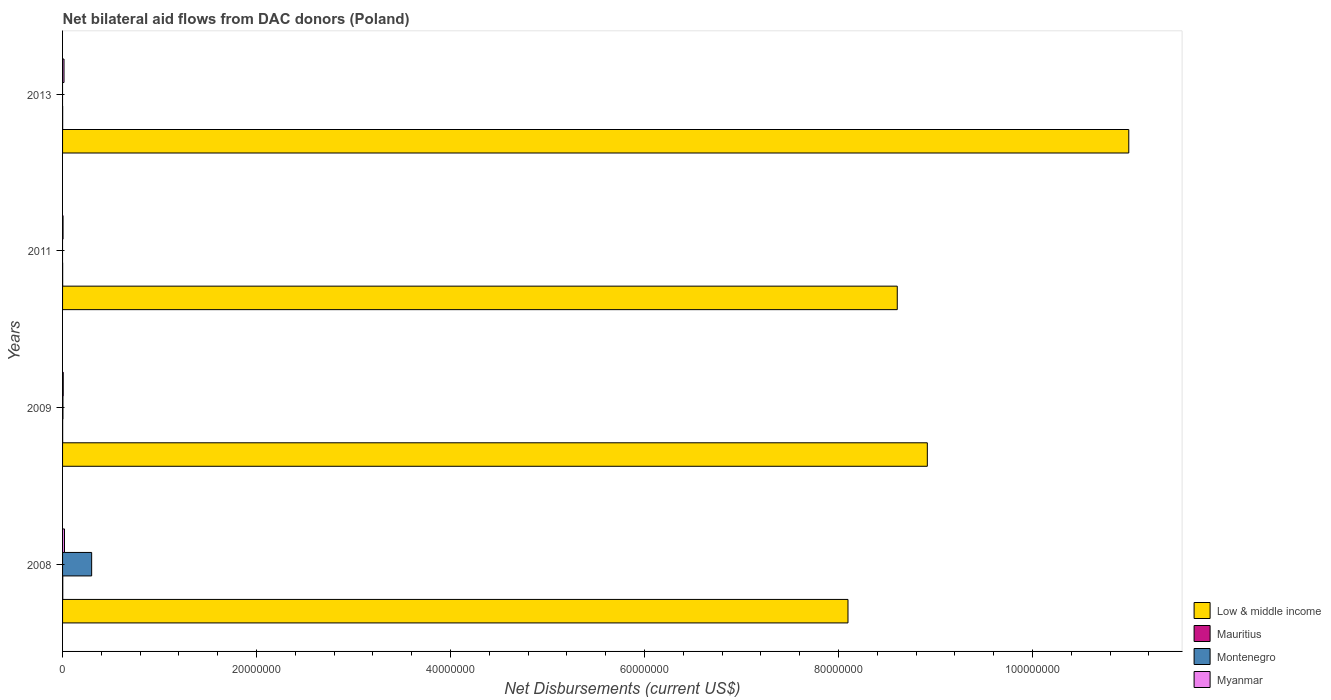Are the number of bars per tick equal to the number of legend labels?
Your answer should be very brief. No. Are the number of bars on each tick of the Y-axis equal?
Your answer should be compact. No. How many bars are there on the 1st tick from the top?
Offer a terse response. 3. How many bars are there on the 1st tick from the bottom?
Your answer should be compact. 4. In how many cases, is the number of bars for a given year not equal to the number of legend labels?
Provide a short and direct response. 2. Across all years, what is the minimum net bilateral aid flows in Montenegro?
Your response must be concise. 0. In which year was the net bilateral aid flows in Mauritius maximum?
Give a very brief answer. 2008. What is the difference between the net bilateral aid flows in Low & middle income in 2009 and the net bilateral aid flows in Montenegro in 2008?
Offer a terse response. 8.62e+07. What is the average net bilateral aid flows in Low & middle income per year?
Give a very brief answer. 9.15e+07. In the year 2008, what is the difference between the net bilateral aid flows in Montenegro and net bilateral aid flows in Mauritius?
Offer a very short reply. 2.98e+06. What is the ratio of the net bilateral aid flows in Low & middle income in 2008 to that in 2011?
Give a very brief answer. 0.94. Is the net bilateral aid flows in Mauritius in 2008 less than that in 2013?
Make the answer very short. No. What is the difference between the highest and the second highest net bilateral aid flows in Low & middle income?
Provide a succinct answer. 2.08e+07. In how many years, is the net bilateral aid flows in Low & middle income greater than the average net bilateral aid flows in Low & middle income taken over all years?
Give a very brief answer. 1. Is the sum of the net bilateral aid flows in Low & middle income in 2009 and 2013 greater than the maximum net bilateral aid flows in Mauritius across all years?
Provide a succinct answer. Yes. Is it the case that in every year, the sum of the net bilateral aid flows in Low & middle income and net bilateral aid flows in Myanmar is greater than the sum of net bilateral aid flows in Montenegro and net bilateral aid flows in Mauritius?
Make the answer very short. Yes. Is it the case that in every year, the sum of the net bilateral aid flows in Low & middle income and net bilateral aid flows in Myanmar is greater than the net bilateral aid flows in Montenegro?
Keep it short and to the point. Yes. Are all the bars in the graph horizontal?
Give a very brief answer. Yes. How many years are there in the graph?
Your answer should be compact. 4. Does the graph contain any zero values?
Ensure brevity in your answer.  Yes. Where does the legend appear in the graph?
Offer a terse response. Bottom right. How are the legend labels stacked?
Your answer should be very brief. Vertical. What is the title of the graph?
Your answer should be compact. Net bilateral aid flows from DAC donors (Poland). What is the label or title of the X-axis?
Give a very brief answer. Net Disbursements (current US$). What is the label or title of the Y-axis?
Offer a very short reply. Years. What is the Net Disbursements (current US$) in Low & middle income in 2008?
Make the answer very short. 8.10e+07. What is the Net Disbursements (current US$) in Montenegro in 2008?
Make the answer very short. 3.00e+06. What is the Net Disbursements (current US$) of Low & middle income in 2009?
Your response must be concise. 8.92e+07. What is the Net Disbursements (current US$) in Mauritius in 2009?
Your answer should be compact. 10000. What is the Net Disbursements (current US$) of Montenegro in 2009?
Give a very brief answer. 4.00e+04. What is the Net Disbursements (current US$) of Myanmar in 2009?
Your answer should be compact. 7.00e+04. What is the Net Disbursements (current US$) in Low & middle income in 2011?
Make the answer very short. 8.61e+07. What is the Net Disbursements (current US$) of Mauritius in 2011?
Your response must be concise. 10000. What is the Net Disbursements (current US$) of Montenegro in 2011?
Your response must be concise. 0. What is the Net Disbursements (current US$) of Myanmar in 2011?
Your response must be concise. 5.00e+04. What is the Net Disbursements (current US$) of Low & middle income in 2013?
Offer a terse response. 1.10e+08. What is the Net Disbursements (current US$) of Mauritius in 2013?
Give a very brief answer. 10000. Across all years, what is the maximum Net Disbursements (current US$) of Low & middle income?
Keep it short and to the point. 1.10e+08. Across all years, what is the maximum Net Disbursements (current US$) of Mauritius?
Give a very brief answer. 2.00e+04. Across all years, what is the minimum Net Disbursements (current US$) of Low & middle income?
Offer a very short reply. 8.10e+07. Across all years, what is the minimum Net Disbursements (current US$) in Mauritius?
Offer a terse response. 10000. Across all years, what is the minimum Net Disbursements (current US$) in Montenegro?
Provide a succinct answer. 0. What is the total Net Disbursements (current US$) of Low & middle income in the graph?
Give a very brief answer. 3.66e+08. What is the total Net Disbursements (current US$) of Mauritius in the graph?
Make the answer very short. 5.00e+04. What is the total Net Disbursements (current US$) in Montenegro in the graph?
Ensure brevity in your answer.  3.04e+06. What is the difference between the Net Disbursements (current US$) in Low & middle income in 2008 and that in 2009?
Ensure brevity in your answer.  -8.18e+06. What is the difference between the Net Disbursements (current US$) of Montenegro in 2008 and that in 2009?
Provide a short and direct response. 2.96e+06. What is the difference between the Net Disbursements (current US$) of Low & middle income in 2008 and that in 2011?
Offer a very short reply. -5.08e+06. What is the difference between the Net Disbursements (current US$) in Myanmar in 2008 and that in 2011?
Your answer should be very brief. 1.50e+05. What is the difference between the Net Disbursements (current US$) of Low & middle income in 2008 and that in 2013?
Your answer should be very brief. -2.90e+07. What is the difference between the Net Disbursements (current US$) in Low & middle income in 2009 and that in 2011?
Make the answer very short. 3.10e+06. What is the difference between the Net Disbursements (current US$) in Low & middle income in 2009 and that in 2013?
Ensure brevity in your answer.  -2.08e+07. What is the difference between the Net Disbursements (current US$) of Myanmar in 2009 and that in 2013?
Provide a succinct answer. -8.00e+04. What is the difference between the Net Disbursements (current US$) in Low & middle income in 2011 and that in 2013?
Provide a short and direct response. -2.39e+07. What is the difference between the Net Disbursements (current US$) of Myanmar in 2011 and that in 2013?
Offer a very short reply. -1.00e+05. What is the difference between the Net Disbursements (current US$) of Low & middle income in 2008 and the Net Disbursements (current US$) of Mauritius in 2009?
Your answer should be compact. 8.10e+07. What is the difference between the Net Disbursements (current US$) of Low & middle income in 2008 and the Net Disbursements (current US$) of Montenegro in 2009?
Keep it short and to the point. 8.09e+07. What is the difference between the Net Disbursements (current US$) of Low & middle income in 2008 and the Net Disbursements (current US$) of Myanmar in 2009?
Ensure brevity in your answer.  8.09e+07. What is the difference between the Net Disbursements (current US$) in Montenegro in 2008 and the Net Disbursements (current US$) in Myanmar in 2009?
Give a very brief answer. 2.93e+06. What is the difference between the Net Disbursements (current US$) in Low & middle income in 2008 and the Net Disbursements (current US$) in Mauritius in 2011?
Make the answer very short. 8.10e+07. What is the difference between the Net Disbursements (current US$) in Low & middle income in 2008 and the Net Disbursements (current US$) in Myanmar in 2011?
Provide a succinct answer. 8.09e+07. What is the difference between the Net Disbursements (current US$) in Mauritius in 2008 and the Net Disbursements (current US$) in Myanmar in 2011?
Your answer should be compact. -3.00e+04. What is the difference between the Net Disbursements (current US$) of Montenegro in 2008 and the Net Disbursements (current US$) of Myanmar in 2011?
Keep it short and to the point. 2.95e+06. What is the difference between the Net Disbursements (current US$) of Low & middle income in 2008 and the Net Disbursements (current US$) of Mauritius in 2013?
Offer a terse response. 8.10e+07. What is the difference between the Net Disbursements (current US$) in Low & middle income in 2008 and the Net Disbursements (current US$) in Myanmar in 2013?
Your answer should be very brief. 8.08e+07. What is the difference between the Net Disbursements (current US$) in Mauritius in 2008 and the Net Disbursements (current US$) in Myanmar in 2013?
Provide a short and direct response. -1.30e+05. What is the difference between the Net Disbursements (current US$) in Montenegro in 2008 and the Net Disbursements (current US$) in Myanmar in 2013?
Provide a short and direct response. 2.85e+06. What is the difference between the Net Disbursements (current US$) of Low & middle income in 2009 and the Net Disbursements (current US$) of Mauritius in 2011?
Provide a succinct answer. 8.92e+07. What is the difference between the Net Disbursements (current US$) of Low & middle income in 2009 and the Net Disbursements (current US$) of Myanmar in 2011?
Your response must be concise. 8.91e+07. What is the difference between the Net Disbursements (current US$) of Low & middle income in 2009 and the Net Disbursements (current US$) of Mauritius in 2013?
Provide a succinct answer. 8.92e+07. What is the difference between the Net Disbursements (current US$) of Low & middle income in 2009 and the Net Disbursements (current US$) of Myanmar in 2013?
Provide a short and direct response. 8.90e+07. What is the difference between the Net Disbursements (current US$) in Mauritius in 2009 and the Net Disbursements (current US$) in Myanmar in 2013?
Give a very brief answer. -1.40e+05. What is the difference between the Net Disbursements (current US$) of Montenegro in 2009 and the Net Disbursements (current US$) of Myanmar in 2013?
Keep it short and to the point. -1.10e+05. What is the difference between the Net Disbursements (current US$) in Low & middle income in 2011 and the Net Disbursements (current US$) in Mauritius in 2013?
Make the answer very short. 8.60e+07. What is the difference between the Net Disbursements (current US$) in Low & middle income in 2011 and the Net Disbursements (current US$) in Myanmar in 2013?
Provide a succinct answer. 8.59e+07. What is the difference between the Net Disbursements (current US$) of Mauritius in 2011 and the Net Disbursements (current US$) of Myanmar in 2013?
Your answer should be compact. -1.40e+05. What is the average Net Disbursements (current US$) of Low & middle income per year?
Your response must be concise. 9.15e+07. What is the average Net Disbursements (current US$) in Mauritius per year?
Your answer should be very brief. 1.25e+04. What is the average Net Disbursements (current US$) of Montenegro per year?
Make the answer very short. 7.60e+05. What is the average Net Disbursements (current US$) of Myanmar per year?
Provide a succinct answer. 1.18e+05. In the year 2008, what is the difference between the Net Disbursements (current US$) in Low & middle income and Net Disbursements (current US$) in Mauritius?
Your response must be concise. 8.10e+07. In the year 2008, what is the difference between the Net Disbursements (current US$) in Low & middle income and Net Disbursements (current US$) in Montenegro?
Your response must be concise. 7.80e+07. In the year 2008, what is the difference between the Net Disbursements (current US$) of Low & middle income and Net Disbursements (current US$) of Myanmar?
Give a very brief answer. 8.08e+07. In the year 2008, what is the difference between the Net Disbursements (current US$) of Mauritius and Net Disbursements (current US$) of Montenegro?
Offer a terse response. -2.98e+06. In the year 2008, what is the difference between the Net Disbursements (current US$) of Mauritius and Net Disbursements (current US$) of Myanmar?
Ensure brevity in your answer.  -1.80e+05. In the year 2008, what is the difference between the Net Disbursements (current US$) in Montenegro and Net Disbursements (current US$) in Myanmar?
Keep it short and to the point. 2.80e+06. In the year 2009, what is the difference between the Net Disbursements (current US$) in Low & middle income and Net Disbursements (current US$) in Mauritius?
Make the answer very short. 8.92e+07. In the year 2009, what is the difference between the Net Disbursements (current US$) of Low & middle income and Net Disbursements (current US$) of Montenegro?
Provide a short and direct response. 8.91e+07. In the year 2009, what is the difference between the Net Disbursements (current US$) of Low & middle income and Net Disbursements (current US$) of Myanmar?
Your answer should be very brief. 8.91e+07. In the year 2009, what is the difference between the Net Disbursements (current US$) of Mauritius and Net Disbursements (current US$) of Montenegro?
Provide a succinct answer. -3.00e+04. In the year 2009, what is the difference between the Net Disbursements (current US$) of Mauritius and Net Disbursements (current US$) of Myanmar?
Give a very brief answer. -6.00e+04. In the year 2009, what is the difference between the Net Disbursements (current US$) in Montenegro and Net Disbursements (current US$) in Myanmar?
Your answer should be very brief. -3.00e+04. In the year 2011, what is the difference between the Net Disbursements (current US$) of Low & middle income and Net Disbursements (current US$) of Mauritius?
Your response must be concise. 8.60e+07. In the year 2011, what is the difference between the Net Disbursements (current US$) of Low & middle income and Net Disbursements (current US$) of Myanmar?
Your answer should be very brief. 8.60e+07. In the year 2011, what is the difference between the Net Disbursements (current US$) in Mauritius and Net Disbursements (current US$) in Myanmar?
Keep it short and to the point. -4.00e+04. In the year 2013, what is the difference between the Net Disbursements (current US$) in Low & middle income and Net Disbursements (current US$) in Mauritius?
Your answer should be compact. 1.10e+08. In the year 2013, what is the difference between the Net Disbursements (current US$) in Low & middle income and Net Disbursements (current US$) in Myanmar?
Your answer should be compact. 1.10e+08. What is the ratio of the Net Disbursements (current US$) of Low & middle income in 2008 to that in 2009?
Ensure brevity in your answer.  0.91. What is the ratio of the Net Disbursements (current US$) in Myanmar in 2008 to that in 2009?
Provide a succinct answer. 2.86. What is the ratio of the Net Disbursements (current US$) of Low & middle income in 2008 to that in 2011?
Make the answer very short. 0.94. What is the ratio of the Net Disbursements (current US$) in Mauritius in 2008 to that in 2011?
Ensure brevity in your answer.  2. What is the ratio of the Net Disbursements (current US$) in Myanmar in 2008 to that in 2011?
Your answer should be compact. 4. What is the ratio of the Net Disbursements (current US$) in Low & middle income in 2008 to that in 2013?
Give a very brief answer. 0.74. What is the ratio of the Net Disbursements (current US$) of Low & middle income in 2009 to that in 2011?
Make the answer very short. 1.04. What is the ratio of the Net Disbursements (current US$) of Myanmar in 2009 to that in 2011?
Your answer should be very brief. 1.4. What is the ratio of the Net Disbursements (current US$) of Low & middle income in 2009 to that in 2013?
Your answer should be very brief. 0.81. What is the ratio of the Net Disbursements (current US$) in Myanmar in 2009 to that in 2013?
Your answer should be very brief. 0.47. What is the ratio of the Net Disbursements (current US$) in Low & middle income in 2011 to that in 2013?
Make the answer very short. 0.78. What is the difference between the highest and the second highest Net Disbursements (current US$) in Low & middle income?
Make the answer very short. 2.08e+07. What is the difference between the highest and the second highest Net Disbursements (current US$) of Myanmar?
Offer a terse response. 5.00e+04. What is the difference between the highest and the lowest Net Disbursements (current US$) of Low & middle income?
Ensure brevity in your answer.  2.90e+07. 